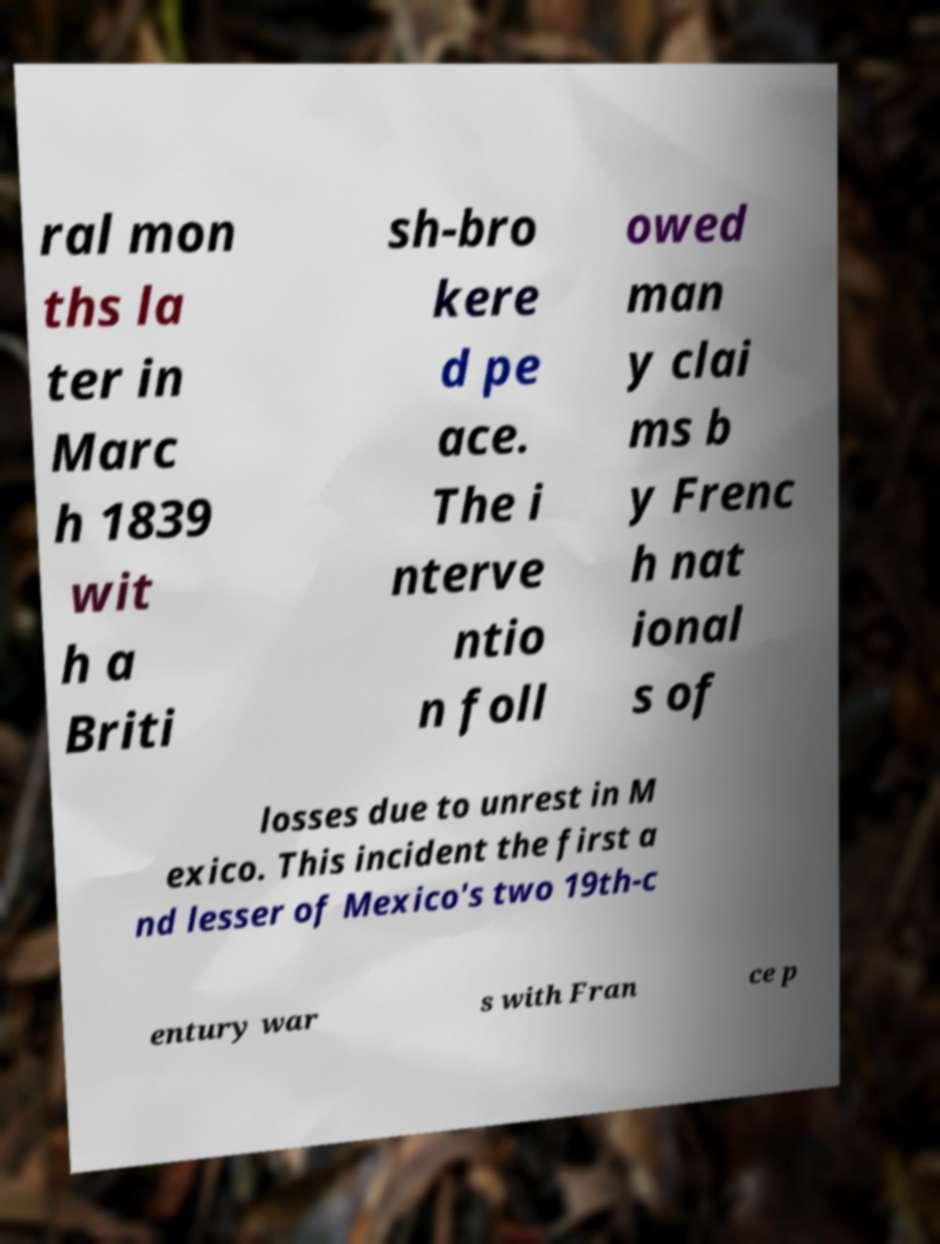What messages or text are displayed in this image? I need them in a readable, typed format. ral mon ths la ter in Marc h 1839 wit h a Briti sh-bro kere d pe ace. The i nterve ntio n foll owed man y clai ms b y Frenc h nat ional s of losses due to unrest in M exico. This incident the first a nd lesser of Mexico's two 19th-c entury war s with Fran ce p 